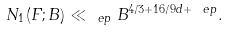<formula> <loc_0><loc_0><loc_500><loc_500>N _ { 1 } ( F ; B ) \ll _ { \ e p } B ^ { 4 / 3 + 1 6 / 9 d + \ e p } .</formula> 